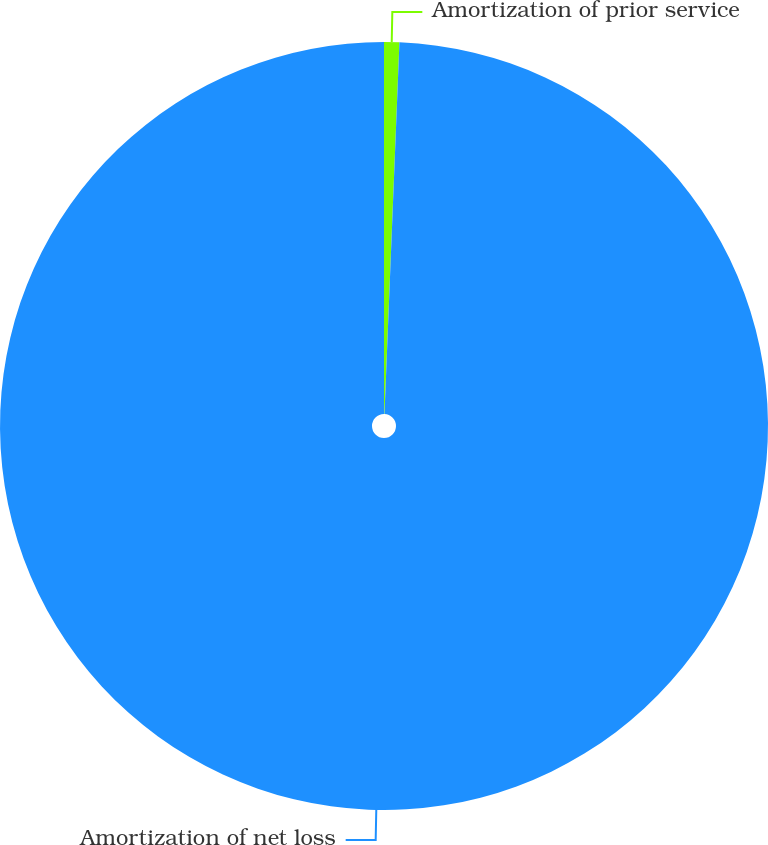<chart> <loc_0><loc_0><loc_500><loc_500><pie_chart><fcel>Amortization of prior service<fcel>Amortization of net loss<nl><fcel>0.64%<fcel>99.36%<nl></chart> 